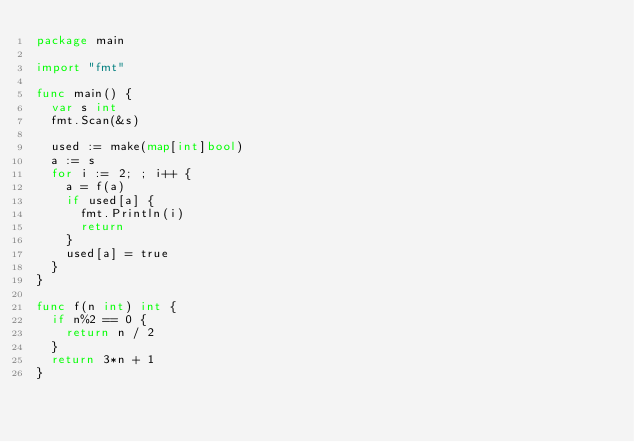<code> <loc_0><loc_0><loc_500><loc_500><_Go_>package main

import "fmt"

func main() {
	var s int
	fmt.Scan(&s)

	used := make(map[int]bool)
	a := s
	for i := 2; ; i++ {
		a = f(a)
		if used[a] {
			fmt.Println(i)
			return
		}
		used[a] = true
	}
}

func f(n int) int {
	if n%2 == 0 {
		return n / 2
	}
	return 3*n + 1
}
</code> 